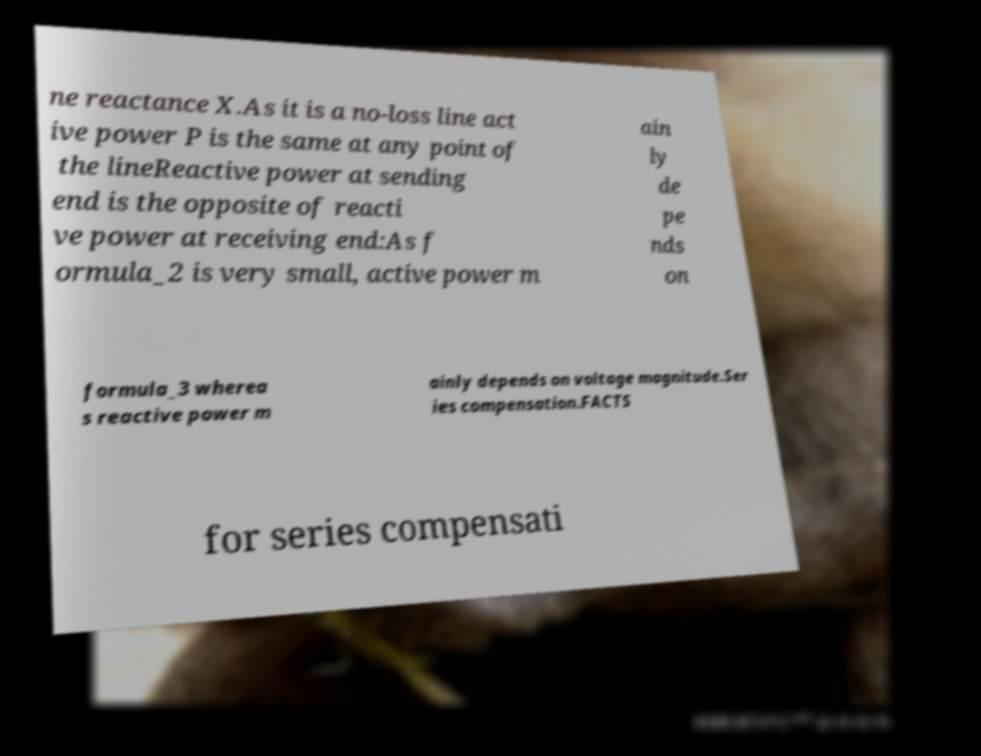Could you assist in decoding the text presented in this image and type it out clearly? ne reactance X.As it is a no-loss line act ive power P is the same at any point of the lineReactive power at sending end is the opposite of reacti ve power at receiving end:As f ormula_2 is very small, active power m ain ly de pe nds on formula_3 wherea s reactive power m ainly depends on voltage magnitude.Ser ies compensation.FACTS for series compensati 